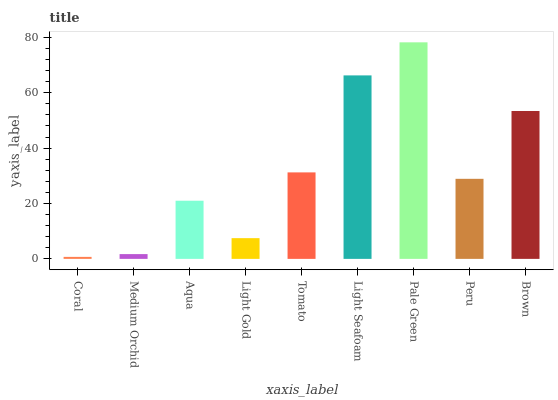Is Coral the minimum?
Answer yes or no. Yes. Is Pale Green the maximum?
Answer yes or no. Yes. Is Medium Orchid the minimum?
Answer yes or no. No. Is Medium Orchid the maximum?
Answer yes or no. No. Is Medium Orchid greater than Coral?
Answer yes or no. Yes. Is Coral less than Medium Orchid?
Answer yes or no. Yes. Is Coral greater than Medium Orchid?
Answer yes or no. No. Is Medium Orchid less than Coral?
Answer yes or no. No. Is Peru the high median?
Answer yes or no. Yes. Is Peru the low median?
Answer yes or no. Yes. Is Light Gold the high median?
Answer yes or no. No. Is Brown the low median?
Answer yes or no. No. 